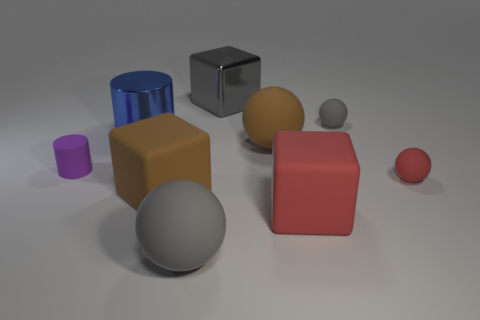There is a purple thing that is the same shape as the big blue object; what is its size?
Offer a very short reply. Small. What is the material of the cylinder that is left of the metallic cylinder?
Provide a short and direct response. Rubber. Are there fewer large cylinders that are in front of the large gray cube than big balls?
Your response must be concise. Yes. There is a gray matte object to the left of the large rubber ball that is to the right of the large gray metallic cube; what shape is it?
Ensure brevity in your answer.  Sphere. The metallic block is what color?
Provide a succinct answer. Gray. How many other objects are the same size as the matte cylinder?
Ensure brevity in your answer.  2. What is the material of the big object that is both behind the brown block and left of the big gray matte sphere?
Ensure brevity in your answer.  Metal. There is a gray rubber thing that is left of the gray shiny block; is it the same size as the large brown rubber block?
Offer a very short reply. Yes. How many matte things are both on the left side of the red cube and right of the large gray matte thing?
Your answer should be compact. 1. How many gray balls are in front of the rubber thing that is on the right side of the gray rubber object behind the blue object?
Your response must be concise. 1. 